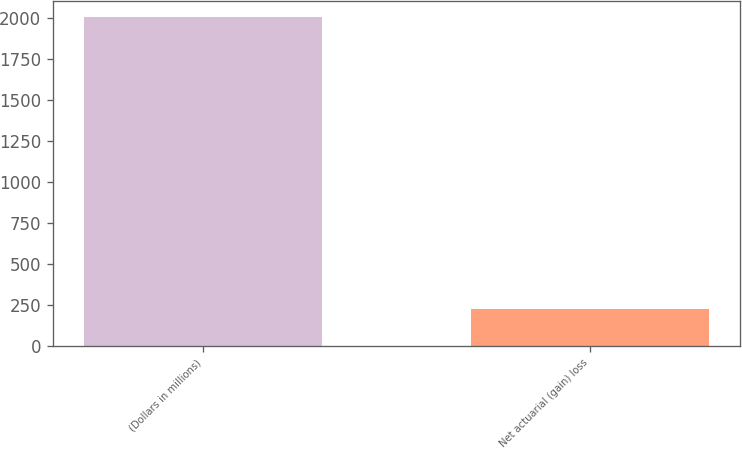<chart> <loc_0><loc_0><loc_500><loc_500><bar_chart><fcel>(Dollars in millions)<fcel>Net actuarial (gain) loss<nl><fcel>2006<fcel>224<nl></chart> 